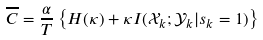<formula> <loc_0><loc_0><loc_500><loc_500>\overline { C } = \frac { \alpha } { T } \left \{ H ( \kappa ) + \kappa I ( \mathcal { X } _ { k } ; \mathcal { Y } _ { k } | s _ { k } = 1 ) \right \}</formula> 